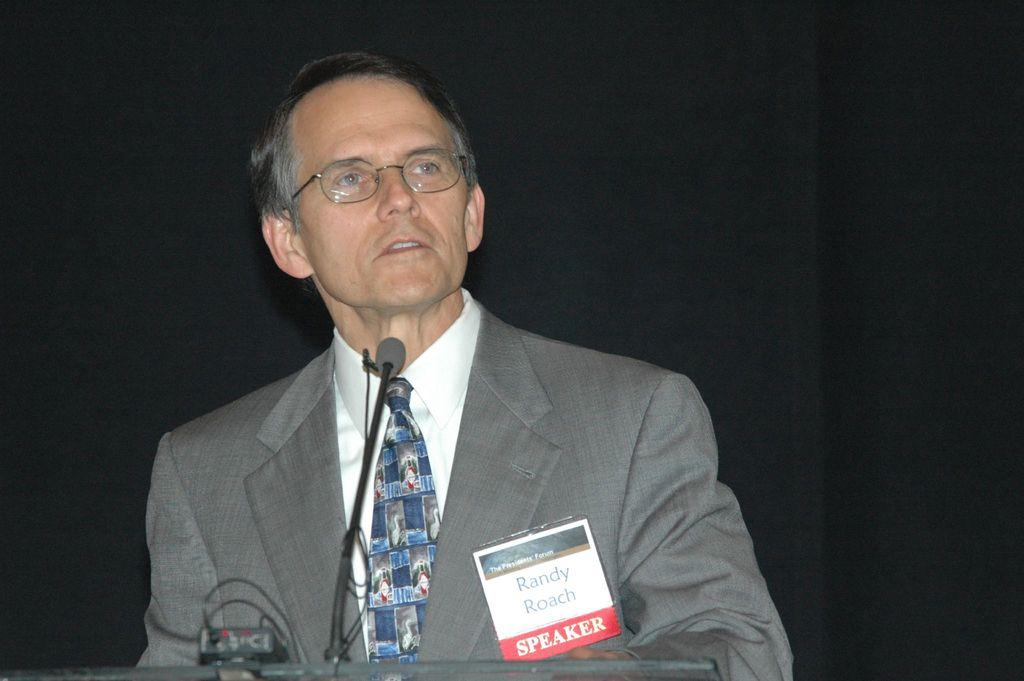Who is the main subject in the image? There is a man standing in the center of the image. What is the man wearing? The man is wearing a suit. What object is in front of the man? There is a podium in front of the man. What is placed on the podium? A microphone is placed on the podium. Can you see a snail crawling on the man's suit in the image? No, there is no snail present in the image. 